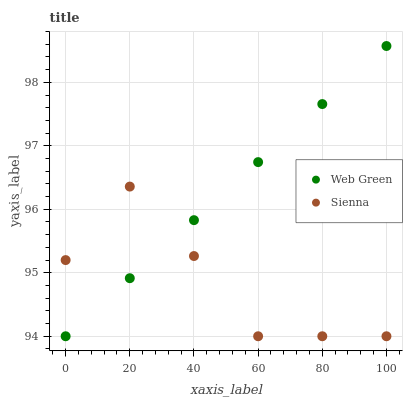Does Sienna have the minimum area under the curve?
Answer yes or no. Yes. Does Web Green have the maximum area under the curve?
Answer yes or no. Yes. Does Web Green have the minimum area under the curve?
Answer yes or no. No. Is Web Green the smoothest?
Answer yes or no. Yes. Is Sienna the roughest?
Answer yes or no. Yes. Is Web Green the roughest?
Answer yes or no. No. Does Sienna have the lowest value?
Answer yes or no. Yes. Does Web Green have the highest value?
Answer yes or no. Yes. Does Sienna intersect Web Green?
Answer yes or no. Yes. Is Sienna less than Web Green?
Answer yes or no. No. Is Sienna greater than Web Green?
Answer yes or no. No. 